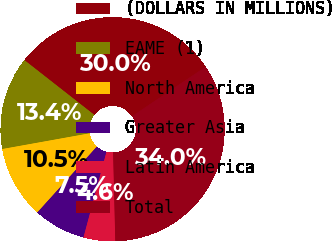Convert chart. <chart><loc_0><loc_0><loc_500><loc_500><pie_chart><fcel>(DOLLARS IN MILLIONS)<fcel>EAME (1)<fcel>North America<fcel>Greater Asia<fcel>Latin America<fcel>Total<nl><fcel>30.0%<fcel>13.41%<fcel>10.47%<fcel>7.52%<fcel>4.57%<fcel>34.03%<nl></chart> 